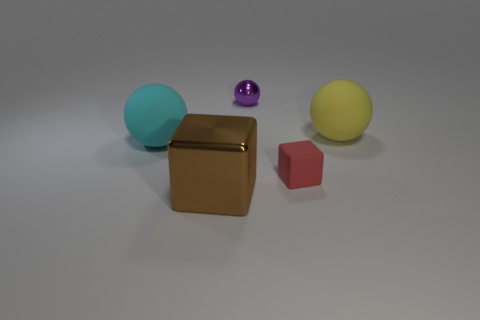There is a tiny purple thing that is the same shape as the cyan object; what is its material?
Offer a very short reply. Metal. Are the small red block and the small purple thing made of the same material?
Your answer should be compact. No. There is a large thing that is in front of the matte thing on the left side of the small purple ball; what is its color?
Make the answer very short. Brown. What size is the cube that is made of the same material as the big cyan sphere?
Give a very brief answer. Small. How many tiny purple metallic objects are the same shape as the large yellow rubber object?
Give a very brief answer. 1. How many objects are either objects that are on the right side of the purple metallic object or rubber things right of the tiny block?
Offer a very short reply. 2. There is a matte ball that is right of the small purple sphere; what number of yellow rubber objects are left of it?
Provide a succinct answer. 0. Does the shiny thing that is to the right of the big brown metal block have the same shape as the large matte thing on the right side of the purple ball?
Offer a very short reply. Yes. Are there any large balls that have the same material as the tiny red cube?
Give a very brief answer. Yes. What number of metallic things are tiny purple balls or big cyan things?
Provide a succinct answer. 1. 